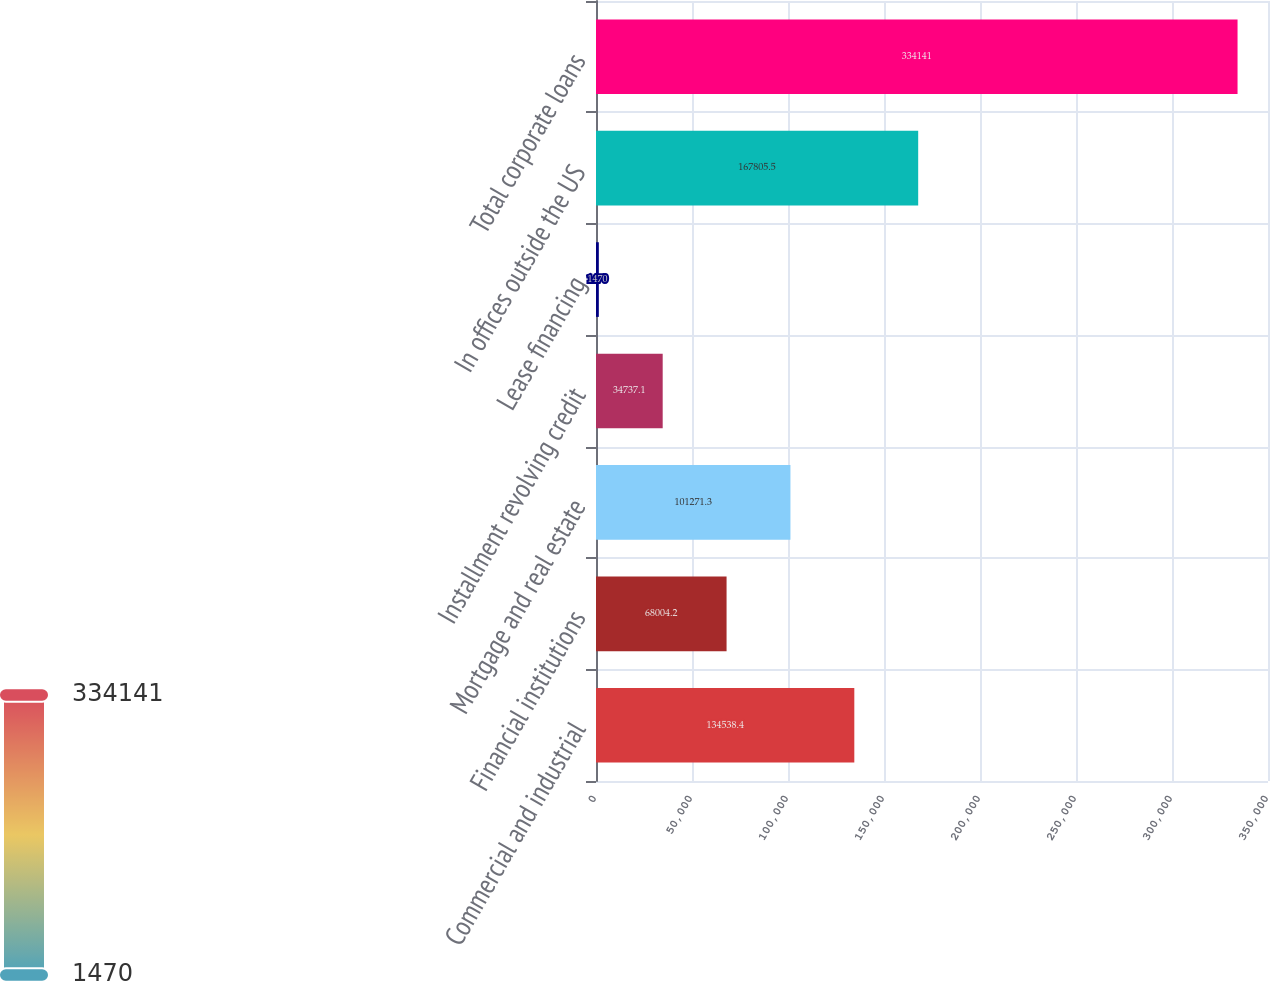<chart> <loc_0><loc_0><loc_500><loc_500><bar_chart><fcel>Commercial and industrial<fcel>Financial institutions<fcel>Mortgage and real estate<fcel>Installment revolving credit<fcel>Lease financing<fcel>In offices outside the US<fcel>Total corporate loans<nl><fcel>134538<fcel>68004.2<fcel>101271<fcel>34737.1<fcel>1470<fcel>167806<fcel>334141<nl></chart> 